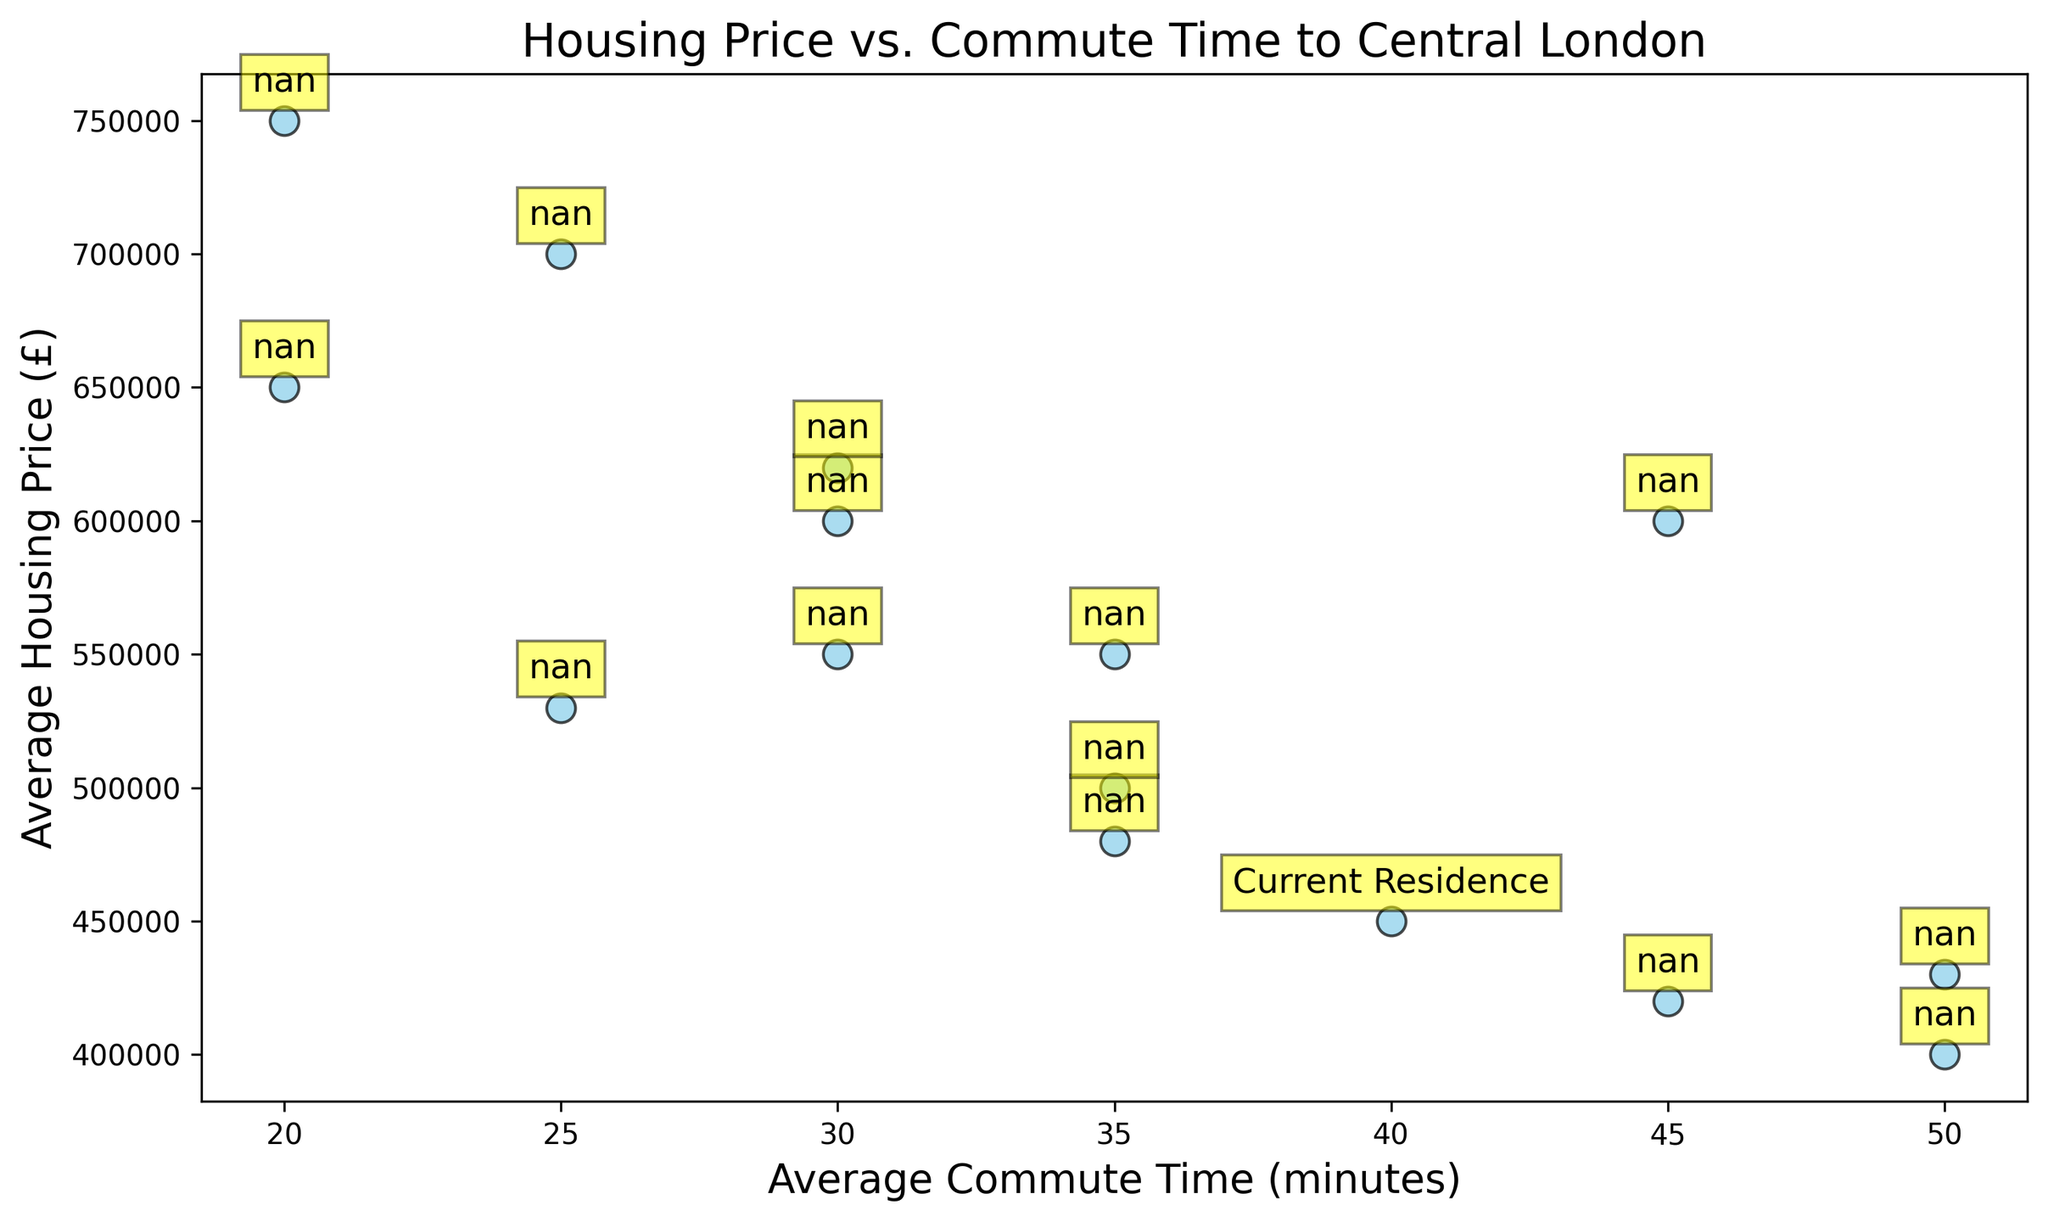What's the average housing price for neighborhoods with a 30-minute commute time? To find this, look at all the neighborhoods with a 30-minute commute (Greenwich, Hackney, Clapham). Add their housing prices together (550000 + 600000 + 620000) and divide by the number of neighborhoods (3).
Answer: 590000 Which neighborhood has the highest average housing price? Look at all the housing prices on the scatter plot. Camden has the highest value on the y-axis at £750,000.
Answer: Camden Which neighborhood has the longest average commute time? On the x-axis, find the data point farthest to the right. Croydon and Enfield both have commute times of 50 minutes.
Answer: Croydon and Enfield Does your current residence (Woolwich East) have a higher or lower housing price compared to Brixton? Refer to the y-axis to compare the heights of the points for Woolwich East (annotated) and Brixton. Woolwich East is at £450,000, while Brixton is at £500,000.
Answer: Lower What is the total number of neighborhoods with an average housing price above £600,000? Identify the neighborhoods with y-values over £600,000 (Canary Wharf, Paddington, Camden, Hackney, Clapham, Kingston). Count them.
Answer: 6 Compare the commute times between Woolwich East and Ilford. Which has a shorter commute? Locate Woolwich East and Ilford on the x-axis. Woolwich East's time is 40 minutes, and Ilford's is 45 minutes.
Answer: Woolwich East Is there a neighborhood with an average housing price of exactly £550,000? Check the y-axis for the value £550,000 and see if any data points align with it. Greenwich and Ealing both are at £550,000.
Answer: Yes, Greenwich and Ealing Which neighborhood, Canary Wharf or Stratford, has a shorter average commute time? Compare their positions on the x-axis. Canary Wharf is at 20 minutes, while Stratford is at 25 minutes.
Answer: Canary Wharf What's the range of average commute times shown in the plot? Find the difference between the maximum and minimum x-values. The longest commute is 50 minutes (Croydon, Enfield) and the shortest is 20 minutes (Canary Wharf, Camden). So, 50 - 20 = 30 minutes.
Answer: 30 minutes Does any neighborhood have the same average housing price as Woolwich East? Identify Woolwich East on the y-axis, which is £450,000. Look for any other points with the same y-value (none).
Answer: No 